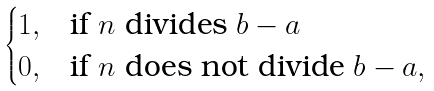Convert formula to latex. <formula><loc_0><loc_0><loc_500><loc_500>\begin{cases} 1 , & \text {if } n \text { divides } b - a \\ 0 , & \text {if } n \text { does not divide } b - a , \end{cases}</formula> 